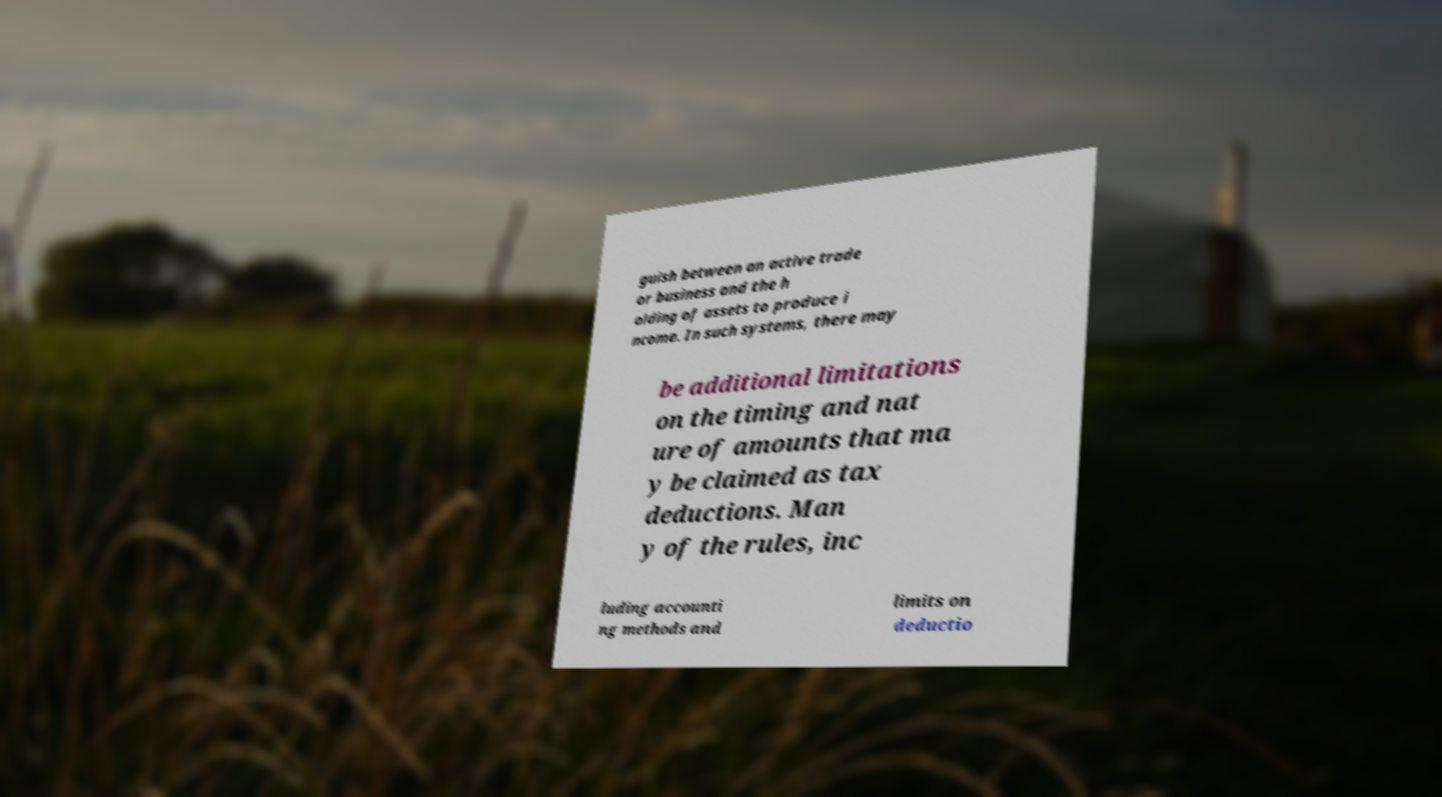Can you accurately transcribe the text from the provided image for me? guish between an active trade or business and the h olding of assets to produce i ncome. In such systems, there may be additional limitations on the timing and nat ure of amounts that ma y be claimed as tax deductions. Man y of the rules, inc luding accounti ng methods and limits on deductio 